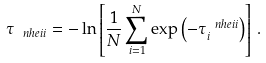<formula> <loc_0><loc_0><loc_500><loc_500>\tau _ { \ n h e i i } = - \ln \left [ \frac { 1 } { N } \sum _ { i = 1 } ^ { N } \exp \left ( - \tau _ { i } ^ { \ n h e i i } \right ) \right ] \, .</formula> 